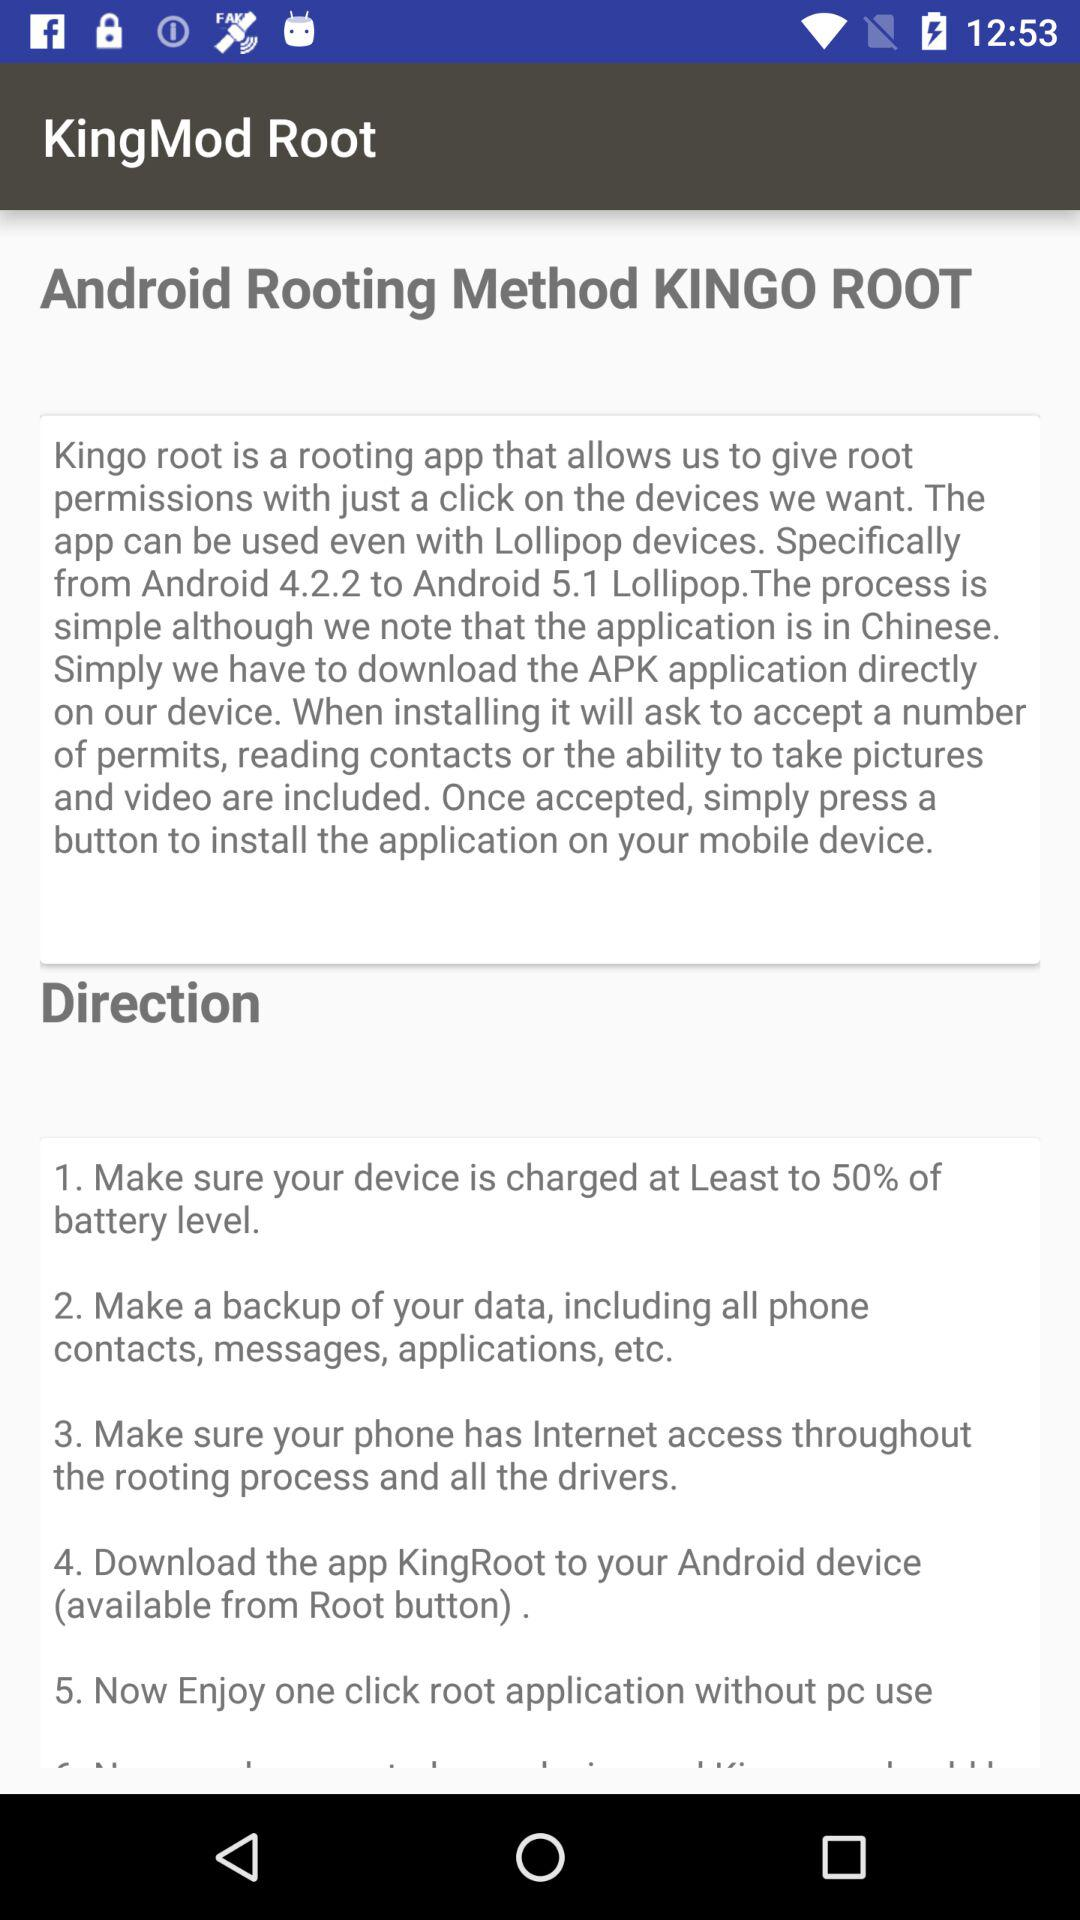What is the Android version range in which this application can be used? The Android version range is from 4.2.2 to 5.1. 